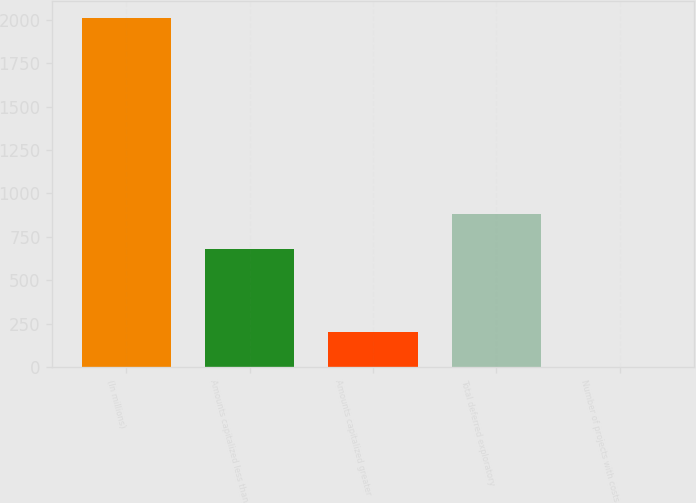Convert chart to OTSL. <chart><loc_0><loc_0><loc_500><loc_500><bar_chart><fcel>(In millions)<fcel>Amounts capitalized less than<fcel>Amounts capitalized greater<fcel>Total deferred exploratory<fcel>Number of projects with costs<nl><fcel>2009<fcel>679<fcel>203.6<fcel>879.6<fcel>3<nl></chart> 